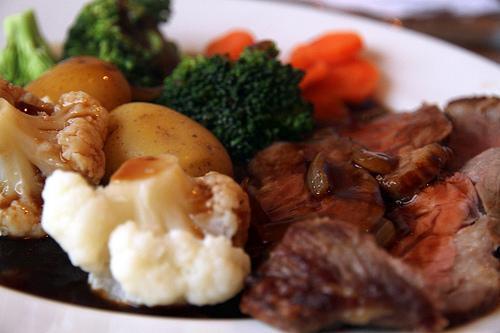How many plates of food are there?
Give a very brief answer. 1. 